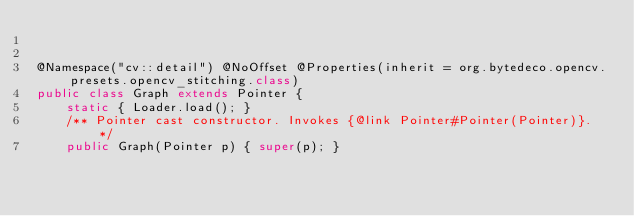Convert code to text. <code><loc_0><loc_0><loc_500><loc_500><_Java_>

@Namespace("cv::detail") @NoOffset @Properties(inherit = org.bytedeco.opencv.presets.opencv_stitching.class)
public class Graph extends Pointer {
    static { Loader.load(); }
    /** Pointer cast constructor. Invokes {@link Pointer#Pointer(Pointer)}. */
    public Graph(Pointer p) { super(p); }
</code> 